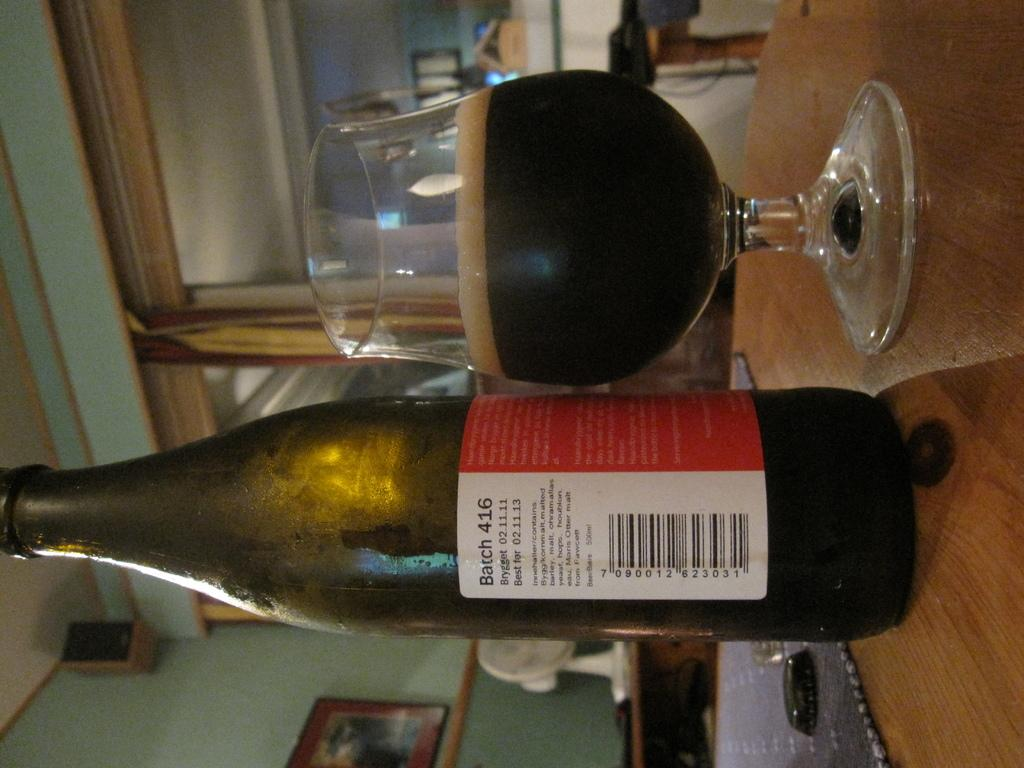<image>
Summarize the visual content of the image. A bottle of Batch 416 is on a table next to a glass filled with a dark liquid. 